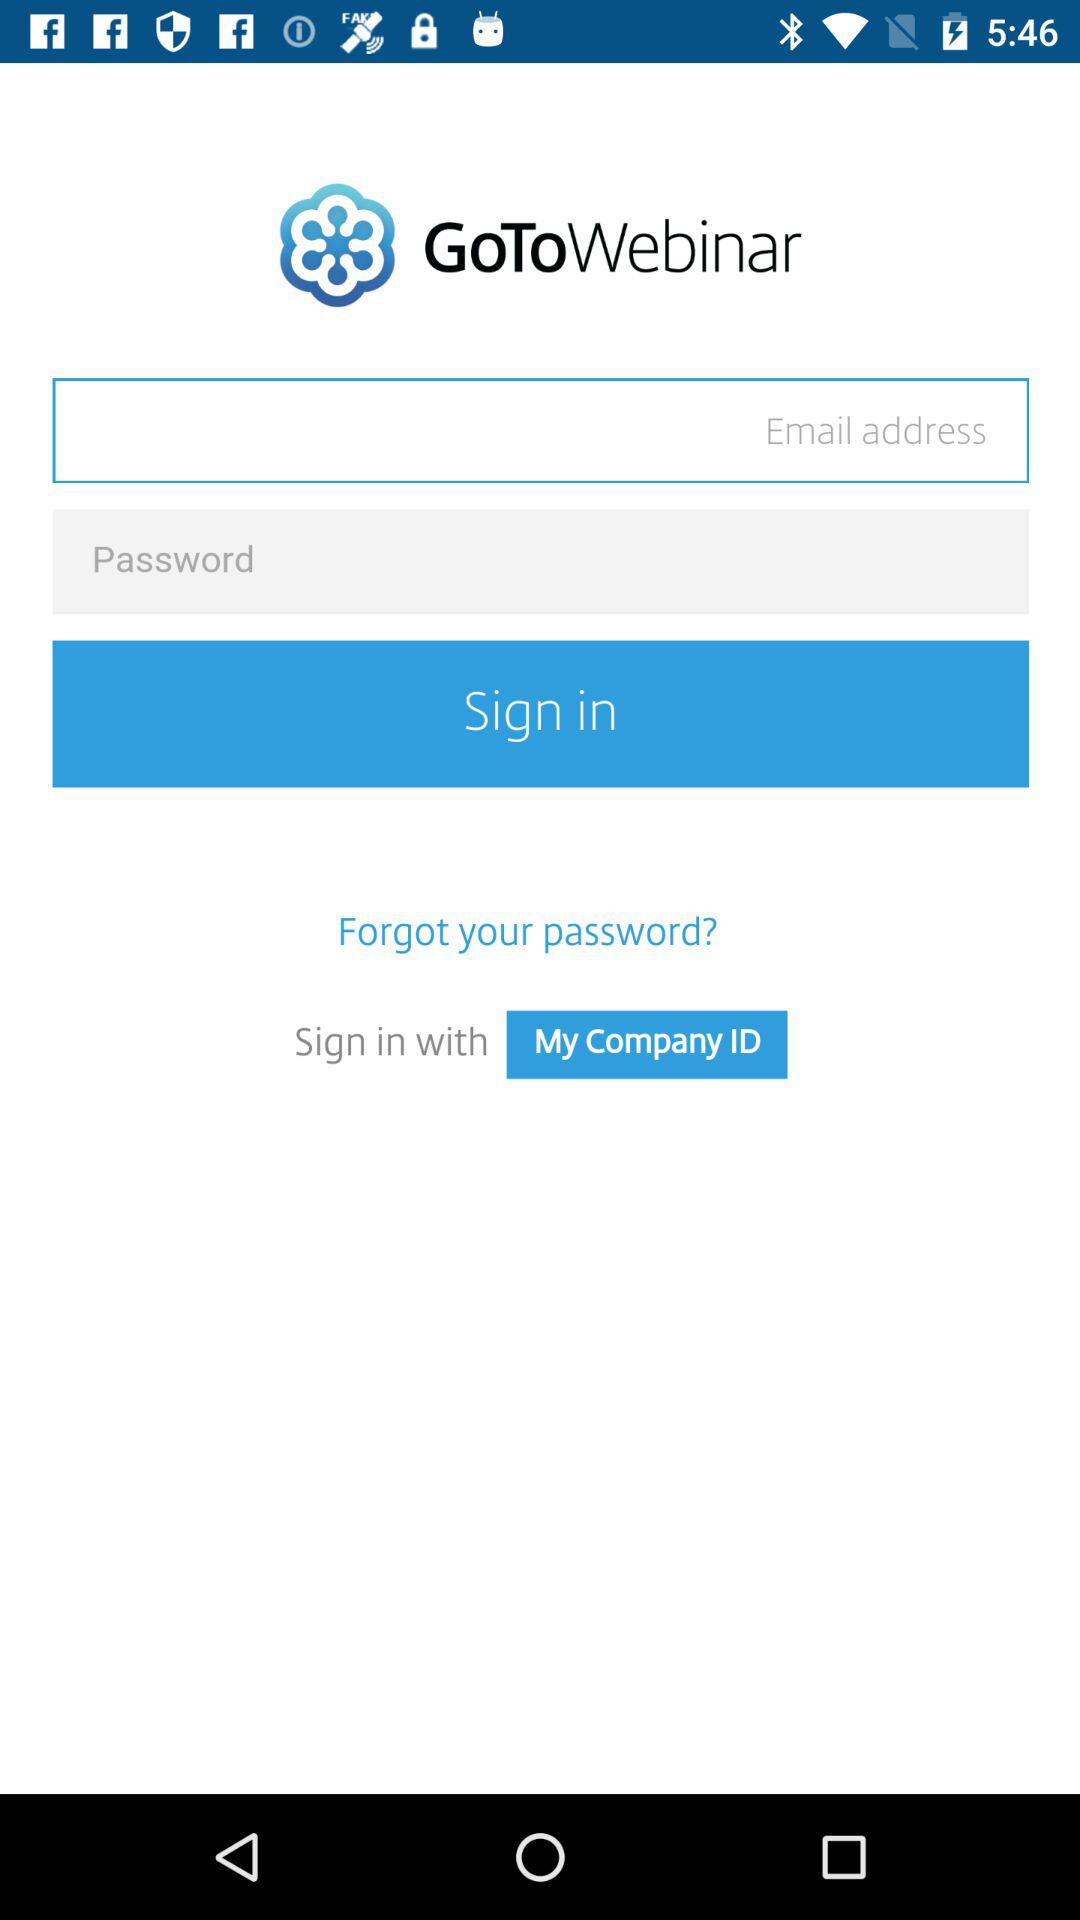What is the name of the application? The name of the application is "GoToWebinar". 